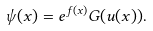<formula> <loc_0><loc_0><loc_500><loc_500>\psi ( x ) = e ^ { f ( x ) } { G ( u ( x ) ) } .</formula> 